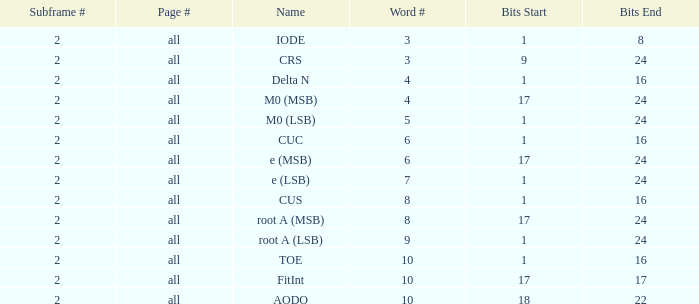What is the typical word count with crs and subframes below 2? None. 